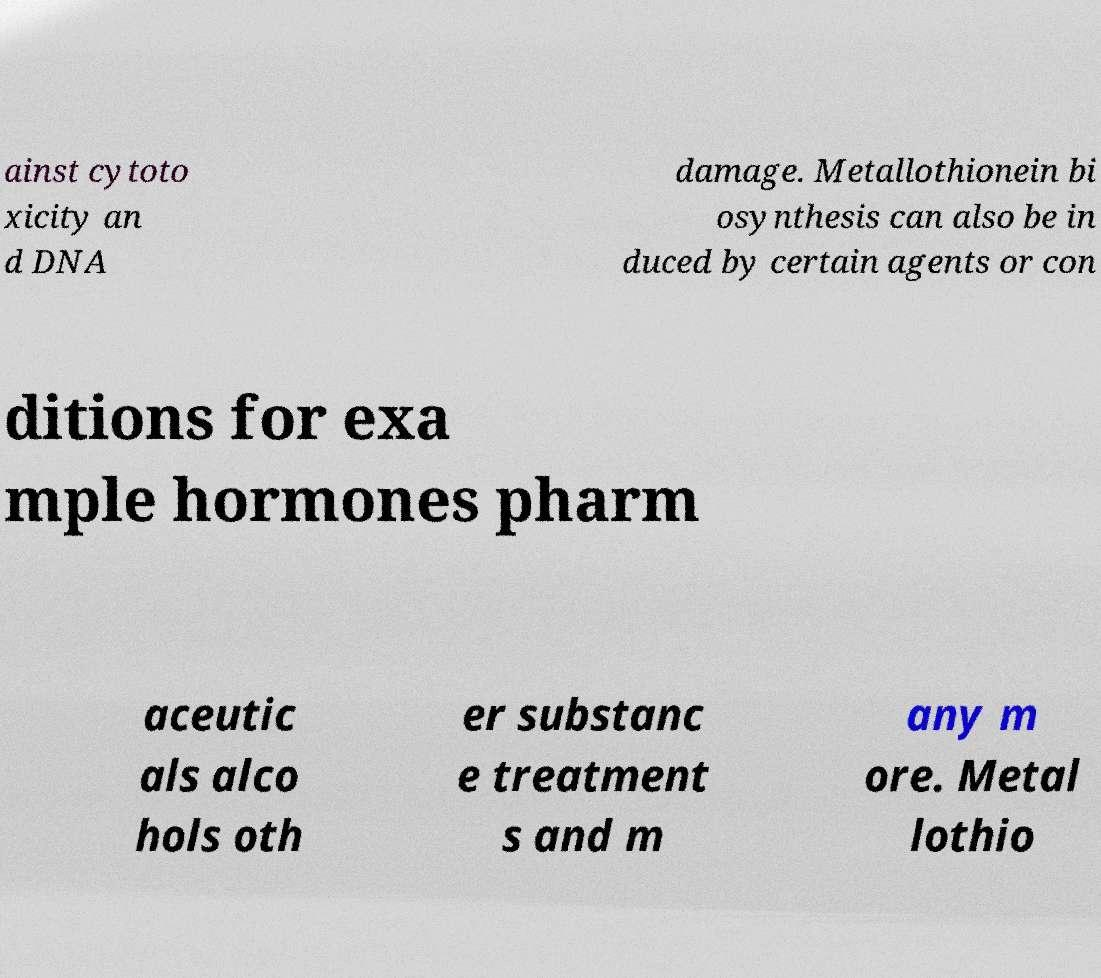There's text embedded in this image that I need extracted. Can you transcribe it verbatim? ainst cytoto xicity an d DNA damage. Metallothionein bi osynthesis can also be in duced by certain agents or con ditions for exa mple hormones pharm aceutic als alco hols oth er substanc e treatment s and m any m ore. Metal lothio 